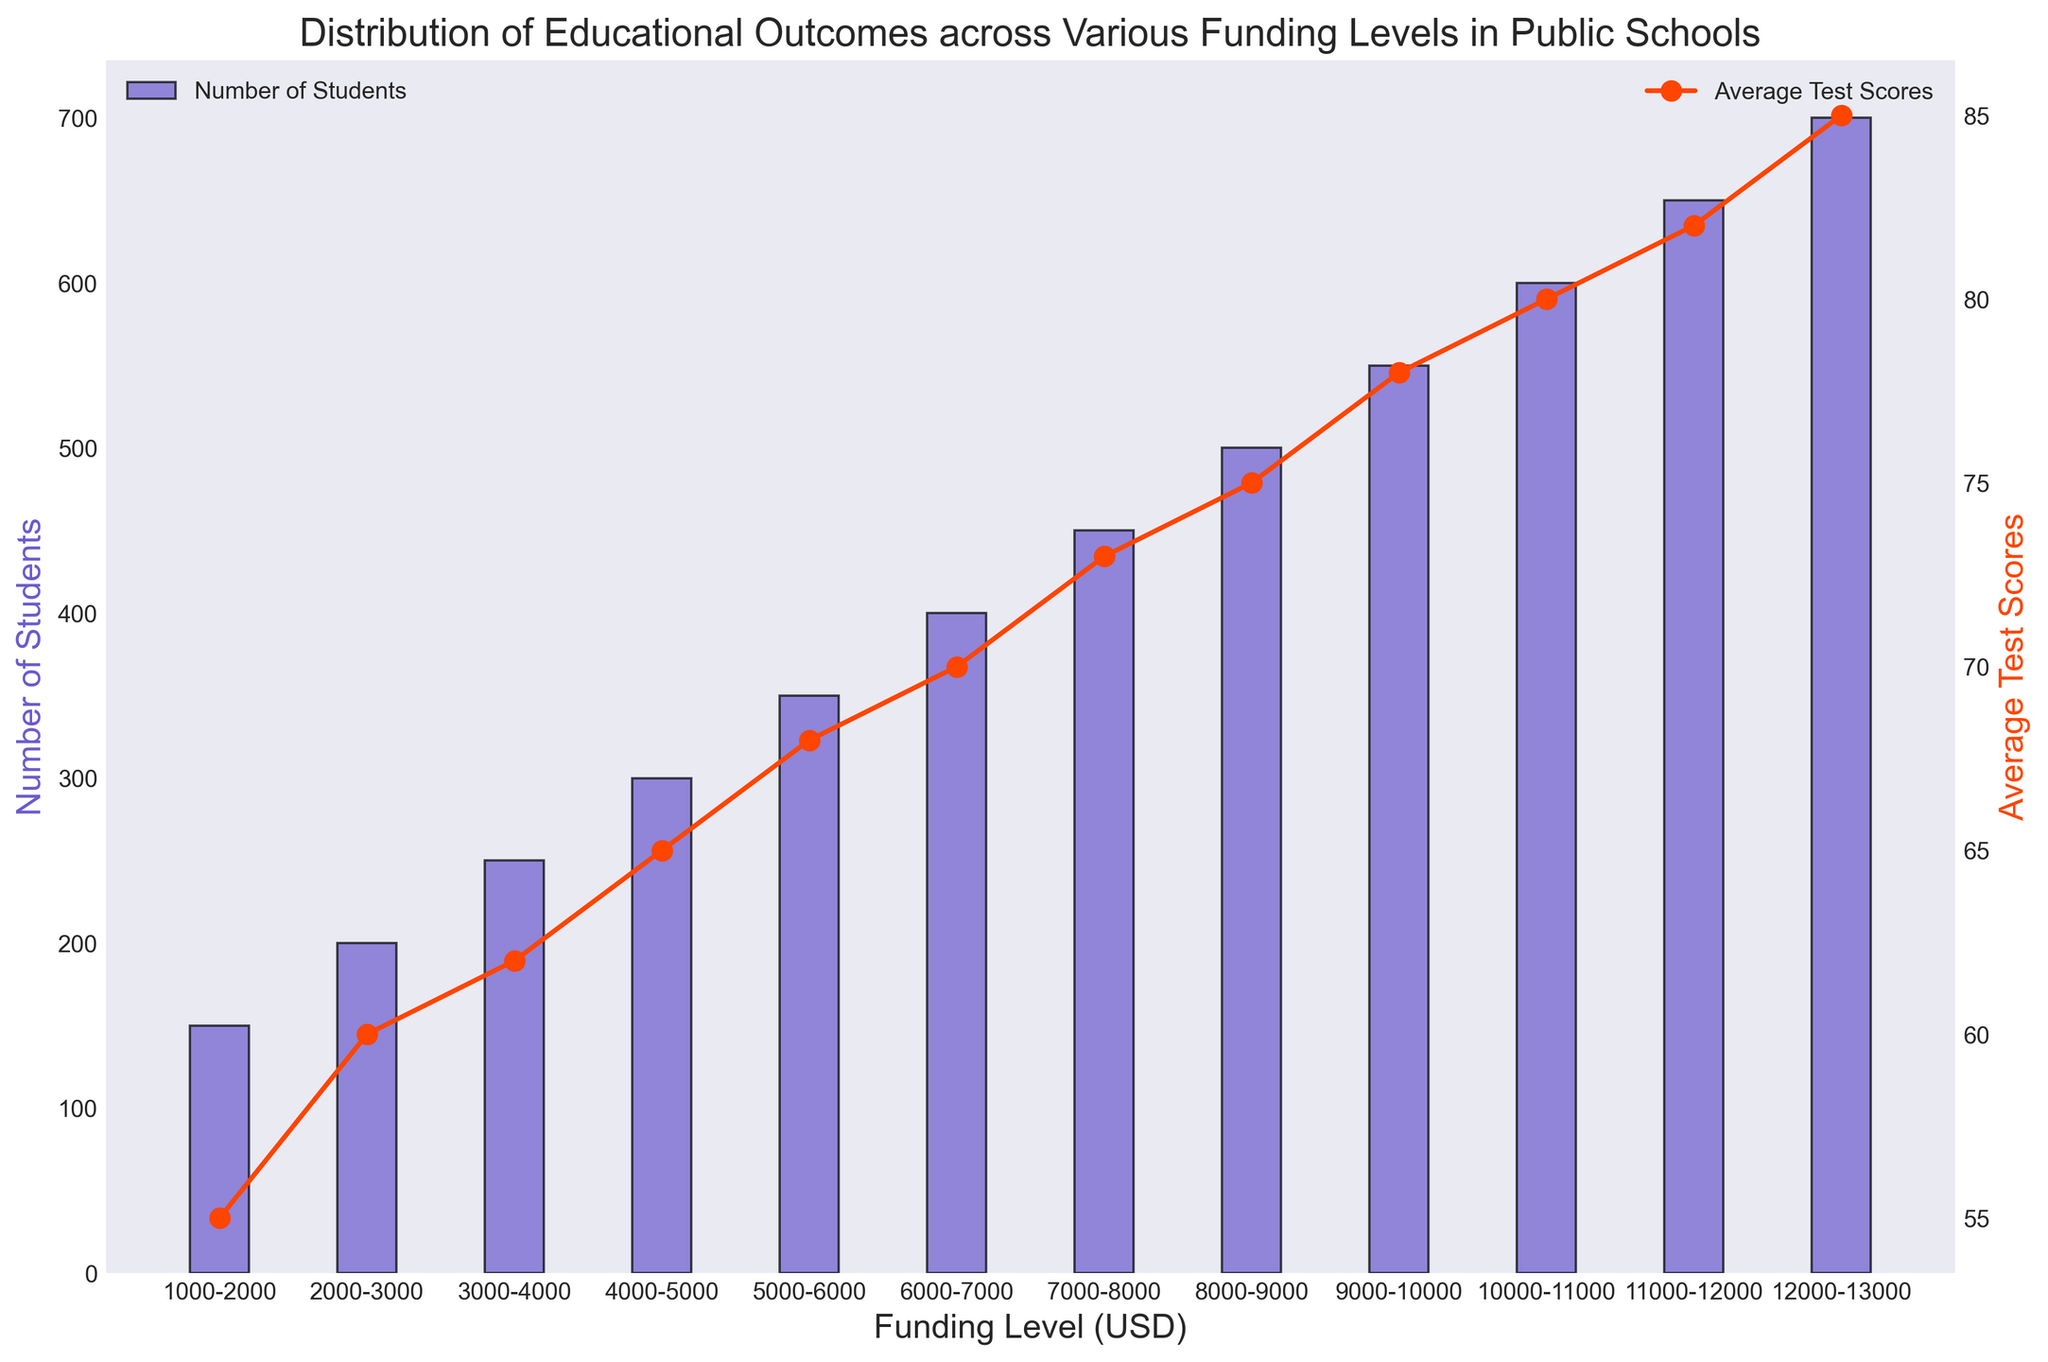What is the funding level with the highest number of students? The bar with the highest height in the histogram represents the highest number of students. In the plot, this occurs at the funding level $12,000-$13,000, where the number of students is 700.
Answer: $12,000-$13,000 Which funding level has the lowest average test scores? The lowest point on the red line graph indicates the funding level with the lowest average test scores. This is at the funding level $1,000-$2,000 with an average test score of 55.
Answer: $1,000-$2,000 Is the number of students always increasing with higher funding levels? Observing the heights of the bars from left to right, each succeeding bar is taller than the previous one, indicating an increasing number of students as funding levels go up.
Answer: Yes At what funding level does the test score average reach 75? Following the red line graph, identify when the y-axis reading for test scores reaches 75. This occurs at the funding level $8,000-$9,000.
Answer: $8,000-$9,000 How much higher are the test scores for the $10,000-$11,000 funding level compared to the $2,000-$3,000 funding level? The test score for $10,000-$11,000 is 80, and for $2,000-$3,000, it is 60. The difference is 80 - 60 = 20.
Answer: 20 Compare the trends in the number of students and average test scores as funding levels increase. What do you observe? Increasing funding levels show a consistent rise in both the number of students (height of bars) and average test scores (height of the red line). This suggests a positive correlation between higher funding and both more students and better test scores.
Answer: Positive correlation Which funding level sees the largest increase in average test scores compared to the previous level? Calculate the differences in average test scores between consecutive funding levels. The largest increase is between $2,000-$3,000 (60) and $3,000-$4,000 (62). The increase is 62 - 60 = 2. Repeat this for all funding levels, and you'll find that the largest increase is from $11,000-$12,000 (82) to $12,000-$13,000 (85), which is an increase of 3.
Answer: $11,000-$12,000 to $12,000-$13,000 At which funding level do the test scores cross the threshold of 70? Along the red line graph, identify the point where it crosses the value of 70. This occurs at the funding level $6,000-$7,000.
Answer: $6,000-$7,000 